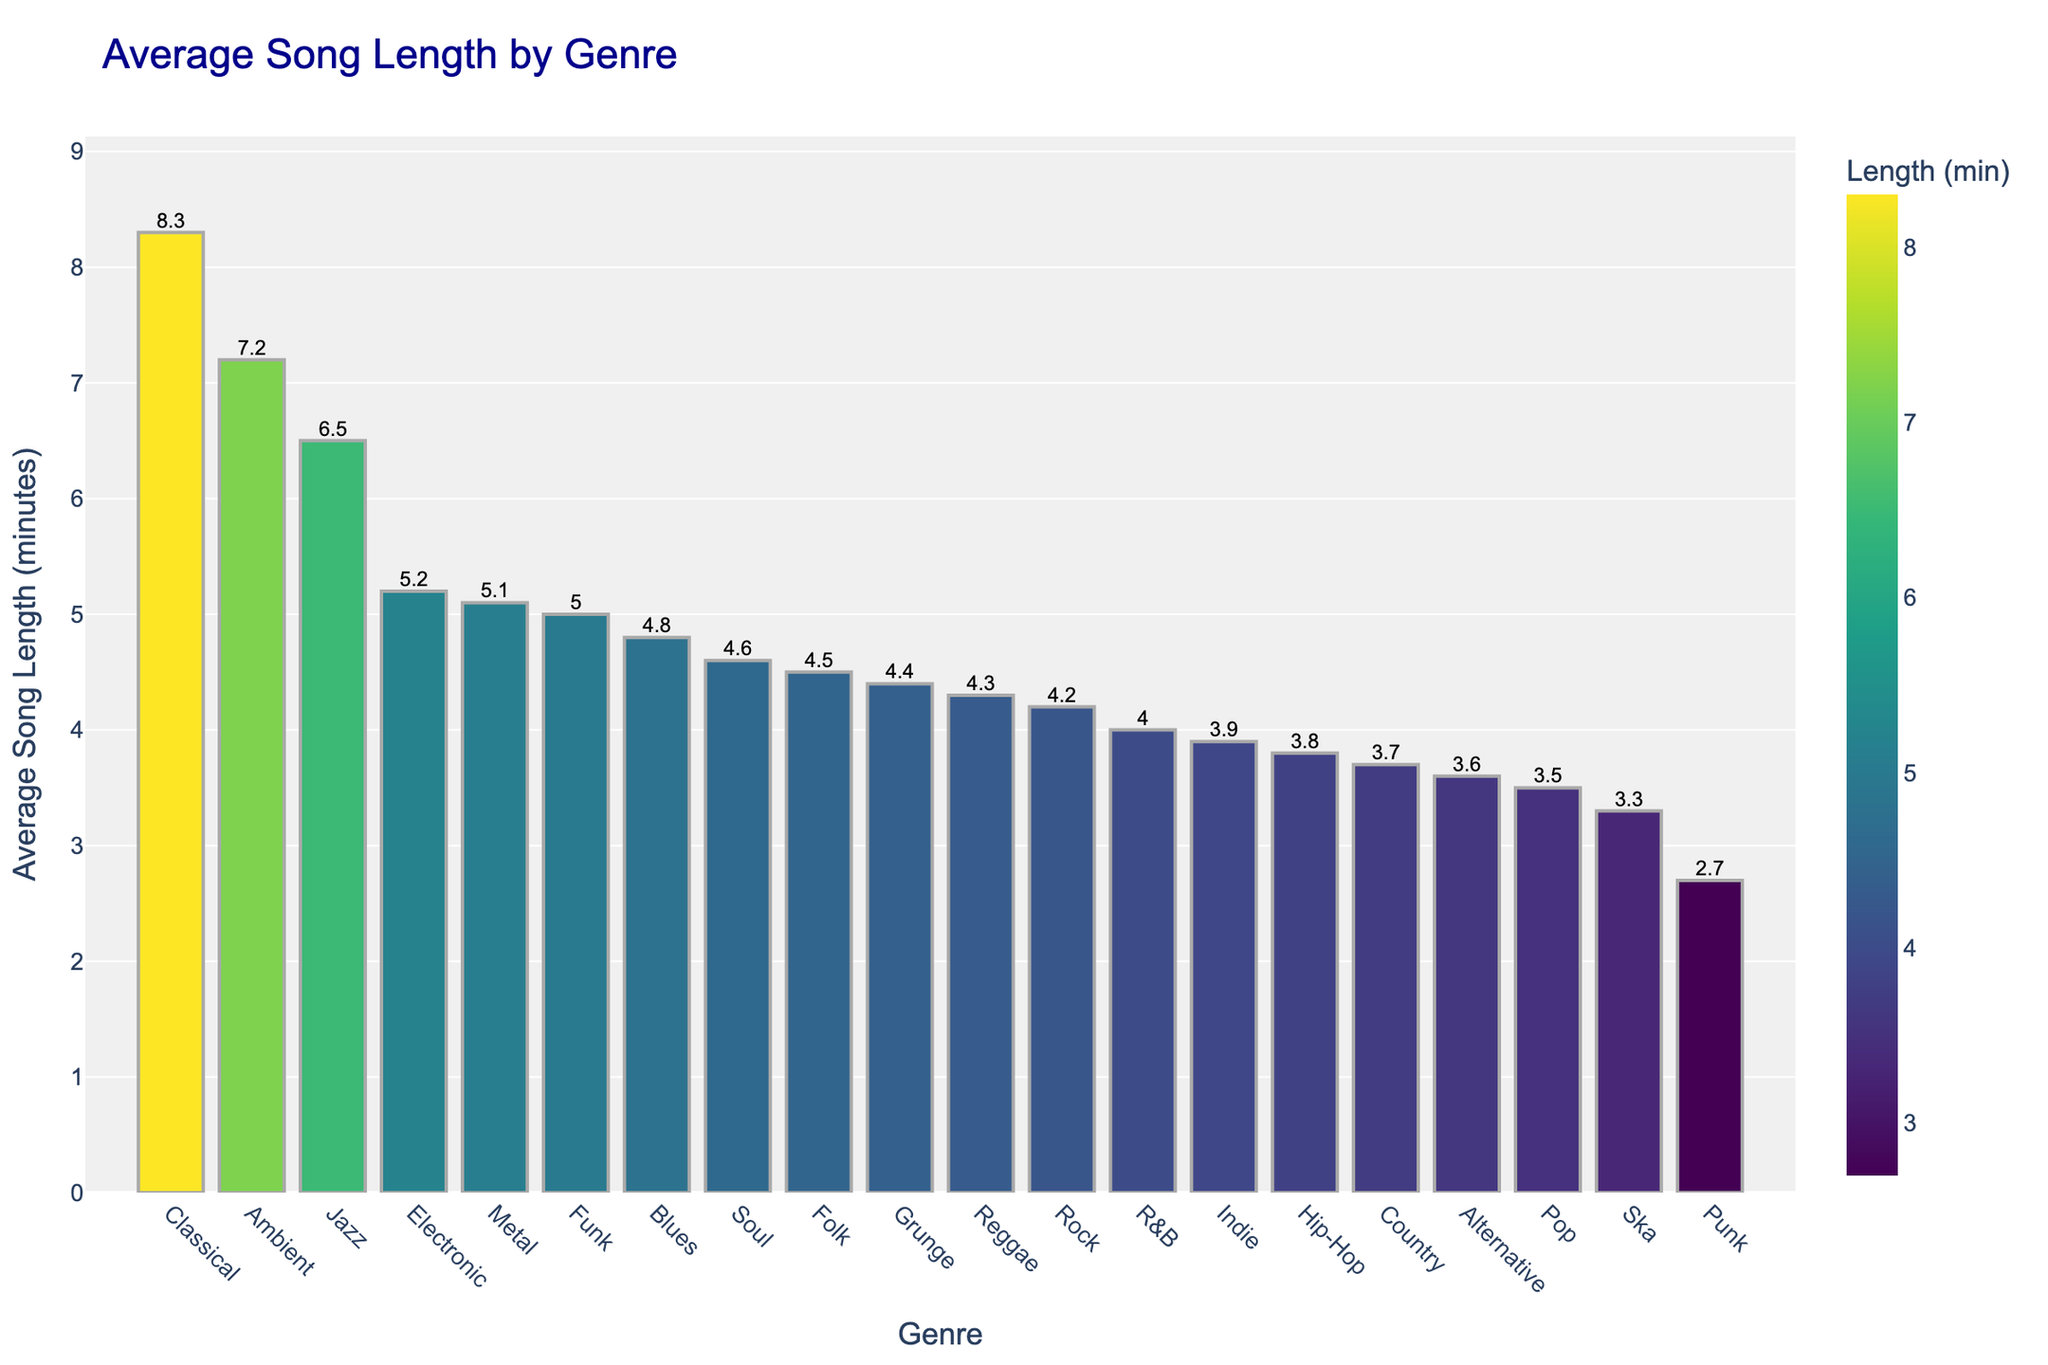What is the average song length for Electronic music? To find the average song length for Electronic music, we look at the bar corresponding to Electronic and see its height or the label on top of the bar.
Answer: 5.2 minutes Which genre has the shortest average song length? To identify the genre with the shortest average song length, we locate the bar that has the smallest height among all the bars in the chart.
Answer: Punk How much longer is the average song length for Classical compared to Pop? First, find the average song length for both Classical and Pop by looking at their respective bars. Classical is 8.3 minutes, and Pop is 3.5 minutes. Subtract Pop's length from Classical's length. 8.3 - 3.5 = 4.8
Answer: 4.8 minutes Rank the top three genres with the longest average song lengths To rank the top three genres, identify the three bars with the greatest heights. These correspond to Classical, Jazz, and Ambient.
Answer: Classical, Jazz, Ambient Is the average song length for Funk music longer than for Indie music? Compare the height of the bar for Funk with the height of the bar for Indie. Funk has an average song length of 5.0 minutes and Indie has 3.9 minutes.
Answer: Yes What is the difference in average song length between Jazz and Blues? Find the average song lengths for Jazz (6.5 minutes) and Blues (4.8 minutes). Calculate the difference by subtracting Blues' length from Jazz's length. 6.5 - 4.8 = 1.7
Answer: 1.7 minutes What visual features help to quickly identify the genre with the longest songs? The tallest bar in the chart is a clear indicator for the genre with the longest songs. The gradient color scale also helps to highlight the longest song lengths as the darkest shade.
Answer: Tallest bar, darkest shade Are there any genres with an average song length exactly between 4 and 5 minutes? Look for bars whose height or label falls within the 4 to 5-minute range. Genres fitting this criterion are Indie (3.9), Funk (5.0), Metal (5.1), and Reggae (4.3).
Answer: Reggae, Soul, Folk Which genre's average song length is closest to the overall average song length of all genres? Calculate the average of the average lengths of all genres. Then, find the genre whose bar is closest in height or labeled value to this average. [(3.5 + 4.2 + 3.8 + 4.0 + 3.7 + 5.2 + 6.5 + 8.3 + 4.5 + 3.9 + 5.1 + 4.3 + 4.8 + 2.7 + 5.0 + 4.6 + 3.6 + 7.2 + 4.4 + 3.3) / 20 = 4.64]. Soul, with an average song length of 4.6, is the closest.
Answer: Soul 